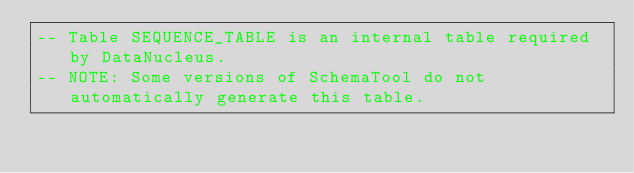<code> <loc_0><loc_0><loc_500><loc_500><_SQL_>-- Table SEQUENCE_TABLE is an internal table required by DataNucleus.
-- NOTE: Some versions of SchemaTool do not automatically generate this table.</code> 